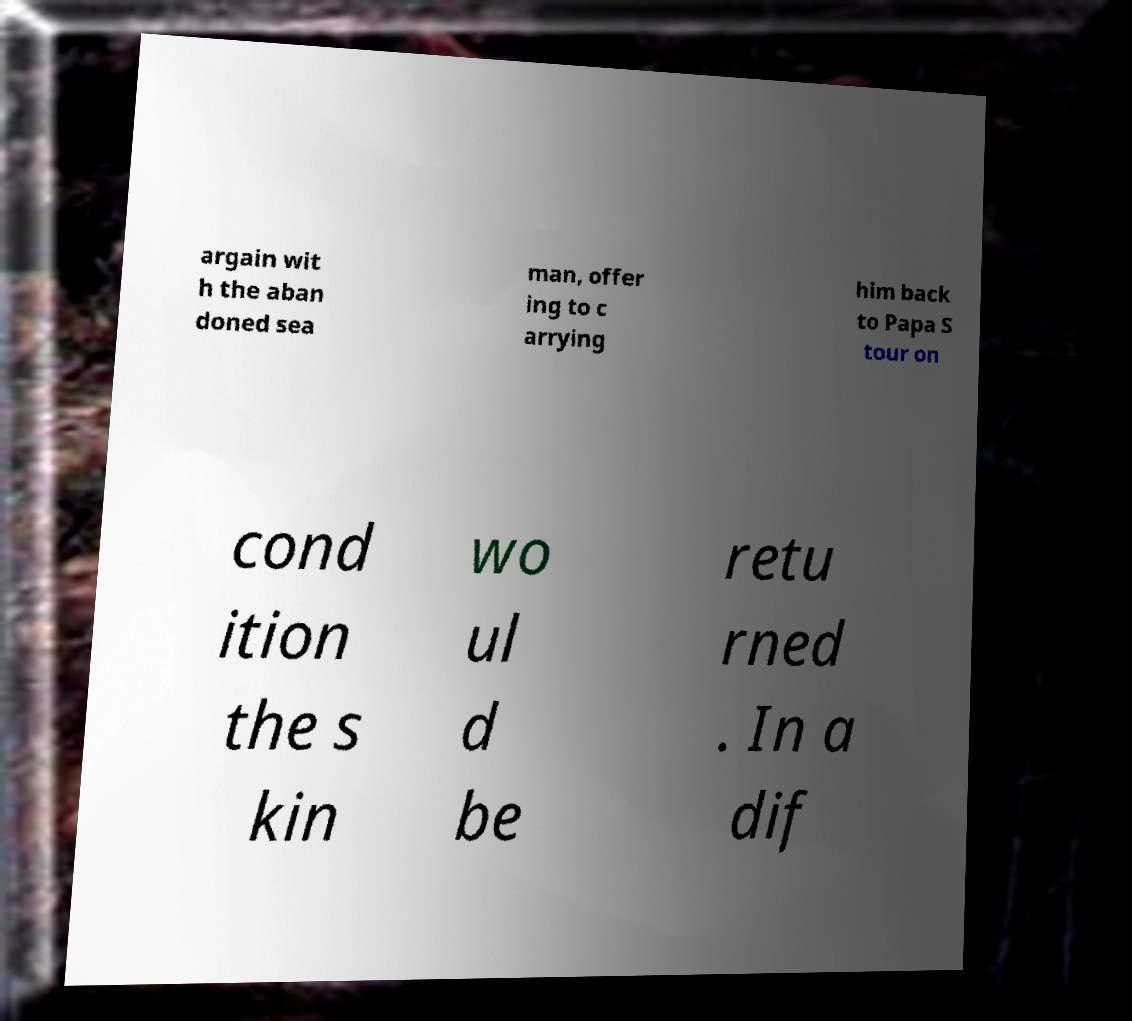Please read and relay the text visible in this image. What does it say? argain wit h the aban doned sea man, offer ing to c arrying him back to Papa S tour on cond ition the s kin wo ul d be retu rned . In a dif 